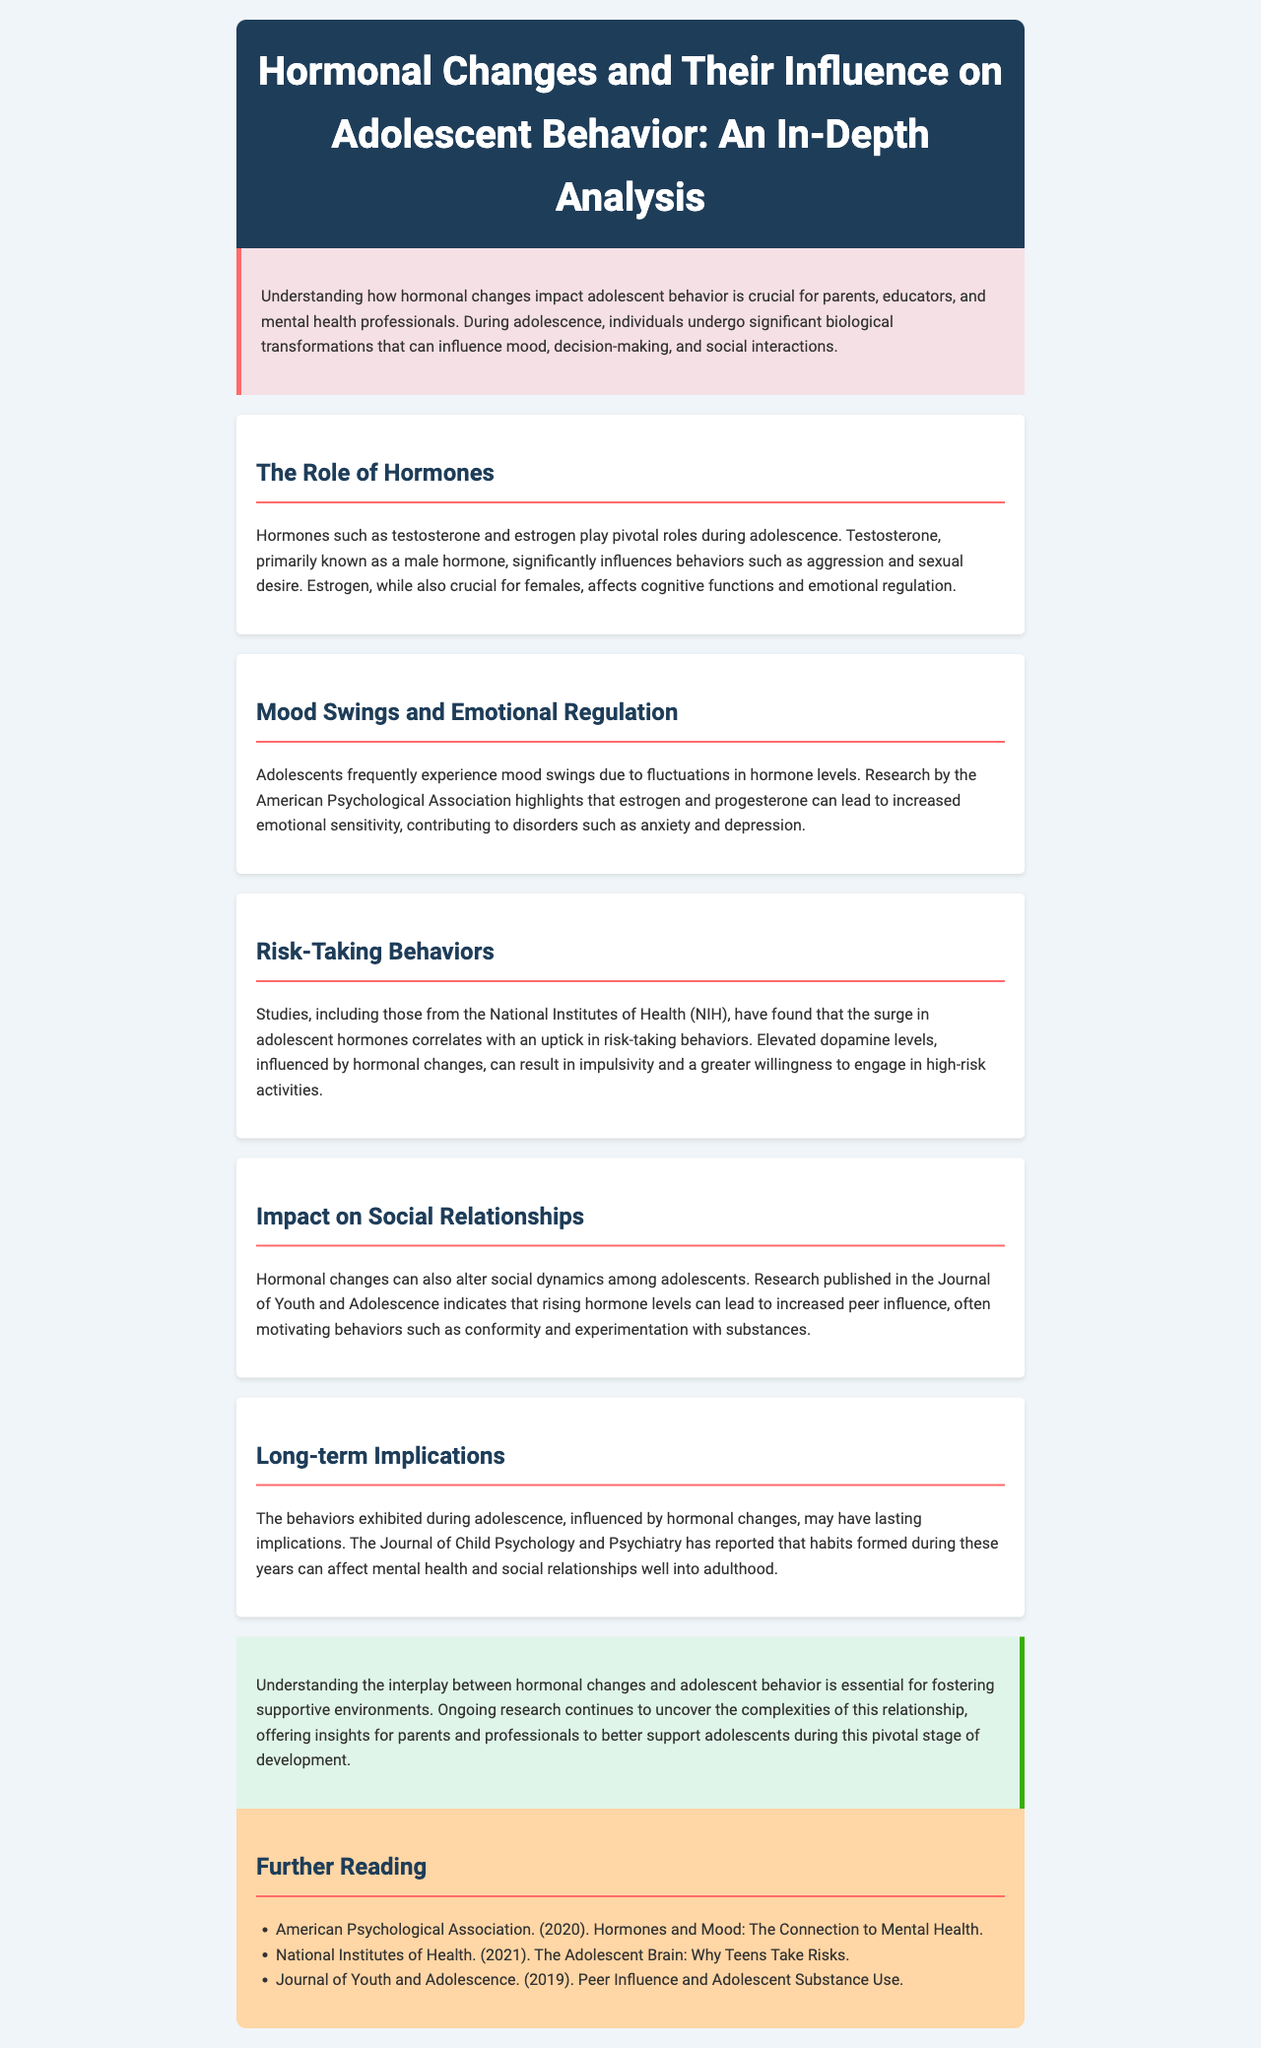What hormones are primarily discussed in relation to adolescent behavior? The hormones discussed in the document that influence adolescent behavior are primarily testosterone and estrogen.
Answer: testosterone and estrogen What does research by the American Psychological Association indicate about hormonal changes? The American Psychological Association's research indicates that estrogen and progesterone can lead to increased emotional sensitivity, contributing to disorders such as anxiety and depression.
Answer: increased emotional sensitivity Which organization reported that the surge in hormones correlates with risk-taking behaviors? The National Institutes of Health reported the correlation between the surge in hormones and risk-taking behaviors.
Answer: National Institutes of Health What is one long-term implication of adolescent behavior influenced by hormones? The long-term implication mentioned is that habits formed during adolescence can affect mental health and social relationships well into adulthood.
Answer: affect mental health and social relationships What is the main focus of the newsletter? The main focus of the newsletter is to analyze the influence of hormonal changes on adolescent behavior.
Answer: influence of hormonal changes on adolescent behavior What section discusses the impact of hormones on social dynamics? The section that discusses the impact of hormones on social dynamics is titled "Impact on Social Relationships."
Answer: Impact on Social Relationships How can parents and professionals support adolescents during hormonal changes? Parents and professionals can support adolescents by understanding the interplay between hormonal changes and behavior.
Answer: understanding the interplay between hormonal changes and behavior 